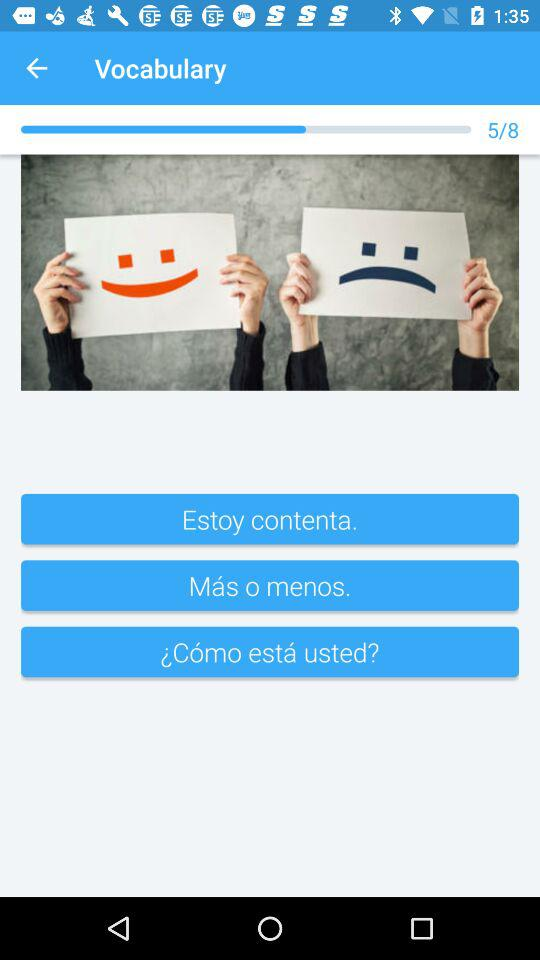What is the name of the application?
When the provided information is insufficient, respond with <no answer>. <no answer> 